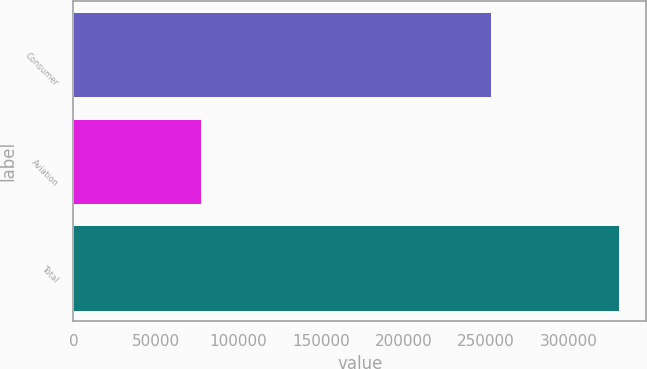Convert chart. <chart><loc_0><loc_0><loc_500><loc_500><bar_chart><fcel>Consumer<fcel>Aviation<fcel>Total<nl><fcel>253153<fcel>77388<fcel>330541<nl></chart> 